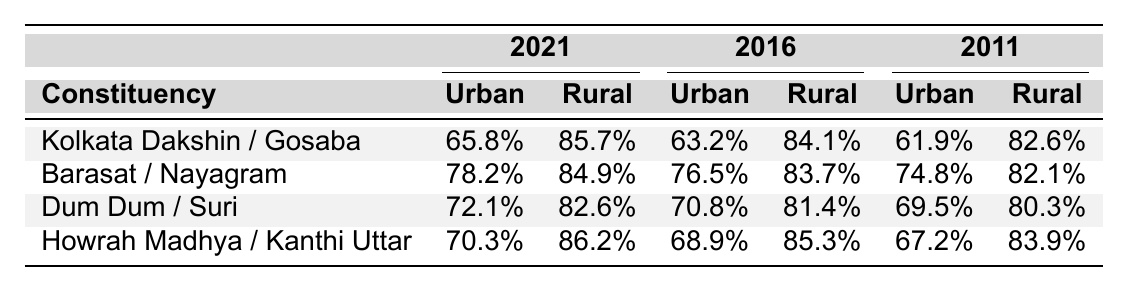What was the voter turnout percentage in the Kolkata Dakshin urban constituency in 2021? The table shows the voter turnout for the Kolkata Dakshin urban constituency in the year 2021, which is explicitly listed as 65.8%.
Answer: 65.8% Which rural constituency had the highest voter turnout in 2016? From the table, we see the rural constituencies' turnout for 2016: Gosaba (84.1%), Nayagram (83.7%), Suri (81.4%), and Kanthi Uttar (85.3%). Comparing these values, Kanthi Uttar has the highest turnout at 85.3%.
Answer: Kanthi Uttar What is the difference in voter turnout between urban and rural constituencies for the Barasat area in 2021? For Barasat in 2021, the urban turnout is 78.2% and the rural turnout is 84.9%. The difference is calculated as 84.9% - 78.2% = 6.7%.
Answer: 6.7% Was there an increase in voter turnout in urban constituencies from 2011 to 2016? The urban constituencies' turnout percentages from the year 2011 is 61.9% for Kolkata Dakshin, 74.8% for Barasat, 69.5% for Dum Dum, and 67.2% for Howrah Madhya. For 2016 the percentages are 63.2%, 76.5%, 70.8%, and 68.9% respectively. By comparing each constituency, we see that only Kolkata Dakshin (61.9% to 63.2%) and Barasat (74.8% to 76.5%) increased, while Dum Dum and Howrah Madhya both decreased. Therefore, it is incorrect to say there was an overall increase.
Answer: No What was the average voter turnout for urban constituencies across all elections? The urban turnout percentages are as follows: 2021 - (65.8% + 78.2% + 72.1% + 70.3%), 2016 - (63.2% + 76.5% + 70.8% + 68.9%), and 2011 - (61.9% + 74.8% + 69.5% + 67.2%). Summing these gives a total of 275.2% for 2021, 279.4% for 2016, and 273.4% for 2011. Combining all gives 275.2 + 279.4 + 273.4 = 828%. There are 12 total data points (4 for each year). Thus, the average is 828% / 12 = 69%.
Answer: 69% Which urban constituency had the greatest change in voter turnout from 2011 to 2021? The urban turnouts for Kolkata Dakshin over the years are 61.9% in 2011 to 65.8% in 2021, a change of +3.9%; for Barasat it’s 74.8% to 78.2%, a change of +3.4%; Dum Dum changes from 69.5% to 72.1%, a change of +2.6%; and Howrah Madhya goes from 67.2% to 70.3%, a change of +3.1%. Kolkata Dakshin has the largest change of +3.9%.
Answer: Kolkata Dakshin Which rural constituency showed the most significant decrease in turnout from 2011 to 2016? Looking at rural constituencies, Gosaba had a turnout of 82.6% in 2011 and decreased to 84.1% in 2016 (an increase), Nayagram changed from 82.1% to 83.7% (an increase), Suri from 80.3% to 81.4% (an increase), and Kanthi Uttar from 83.9% to 85.3% (an increase). Since all rural constituencies improved in turnout, there was no decrease in any rural constituency for these years.
Answer: None What was the rural constituency turnout in 2011, which had a percentage lower than any urban constituency in that same year? The urban turnout percentages in 2011 were: Kolkata Dakshin (61.9%), Barasat (74.8%), Dum Dum (69.5%), and Howrah Madhya (67.2%). The rural turnout percentages were: Gosaba (82.6%), Nayagram (82.1%), Suri (80.3%), and Kanthi Uttar (83.9%). All rural constituency turnouts in 2011 were higher than urban constituencies in the same year.
Answer: None 